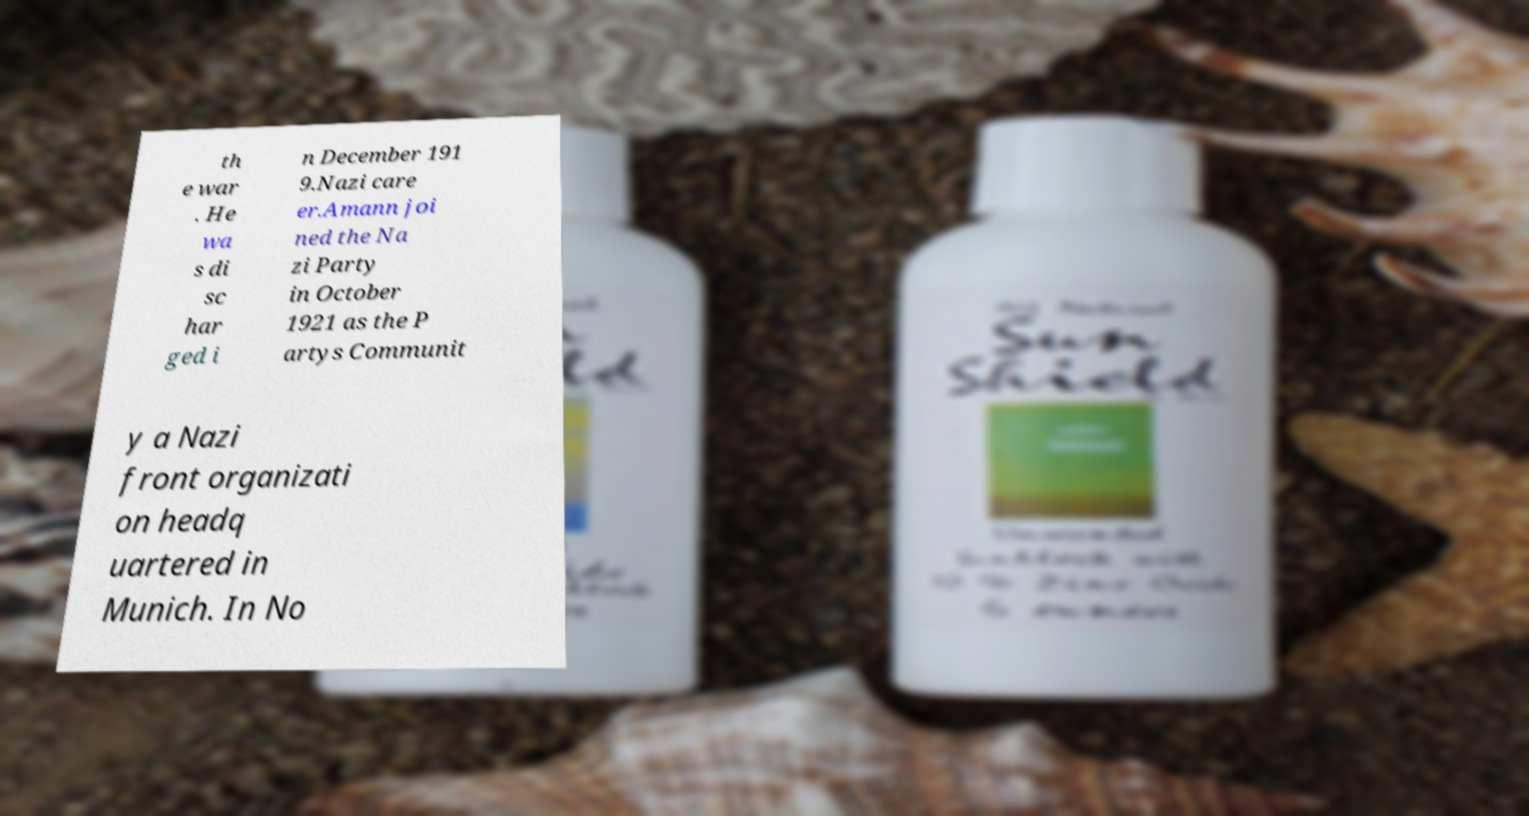Could you extract and type out the text from this image? th e war . He wa s di sc har ged i n December 191 9.Nazi care er.Amann joi ned the Na zi Party in October 1921 as the P artys Communit y a Nazi front organizati on headq uartered in Munich. In No 